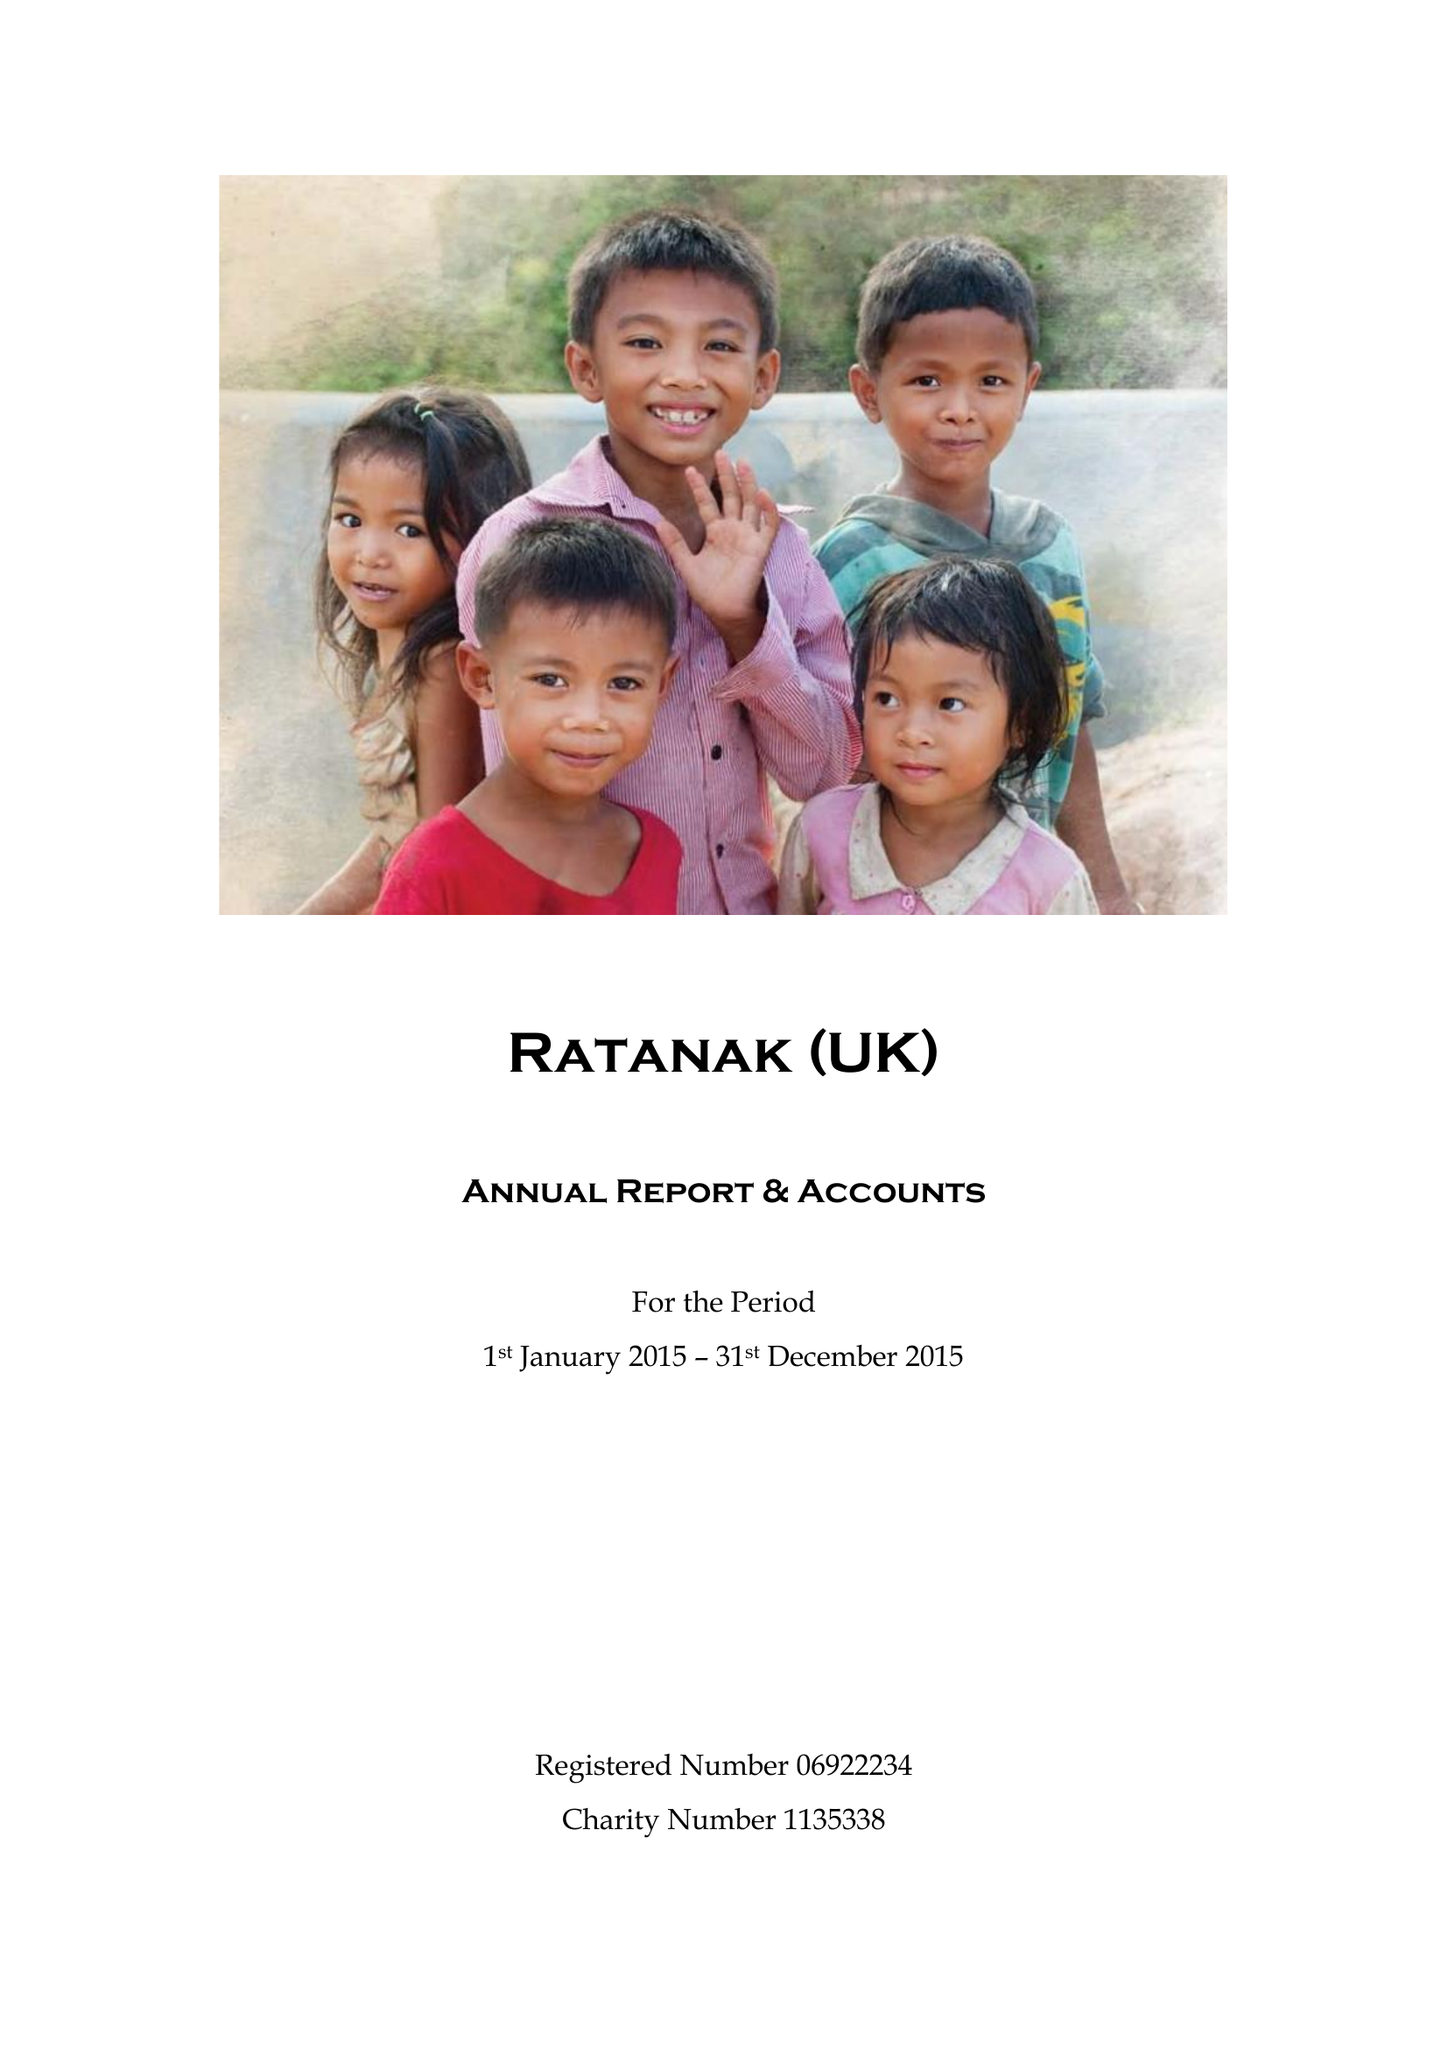What is the value for the charity_name?
Answer the question using a single word or phrase. Ratanak (Uk) 